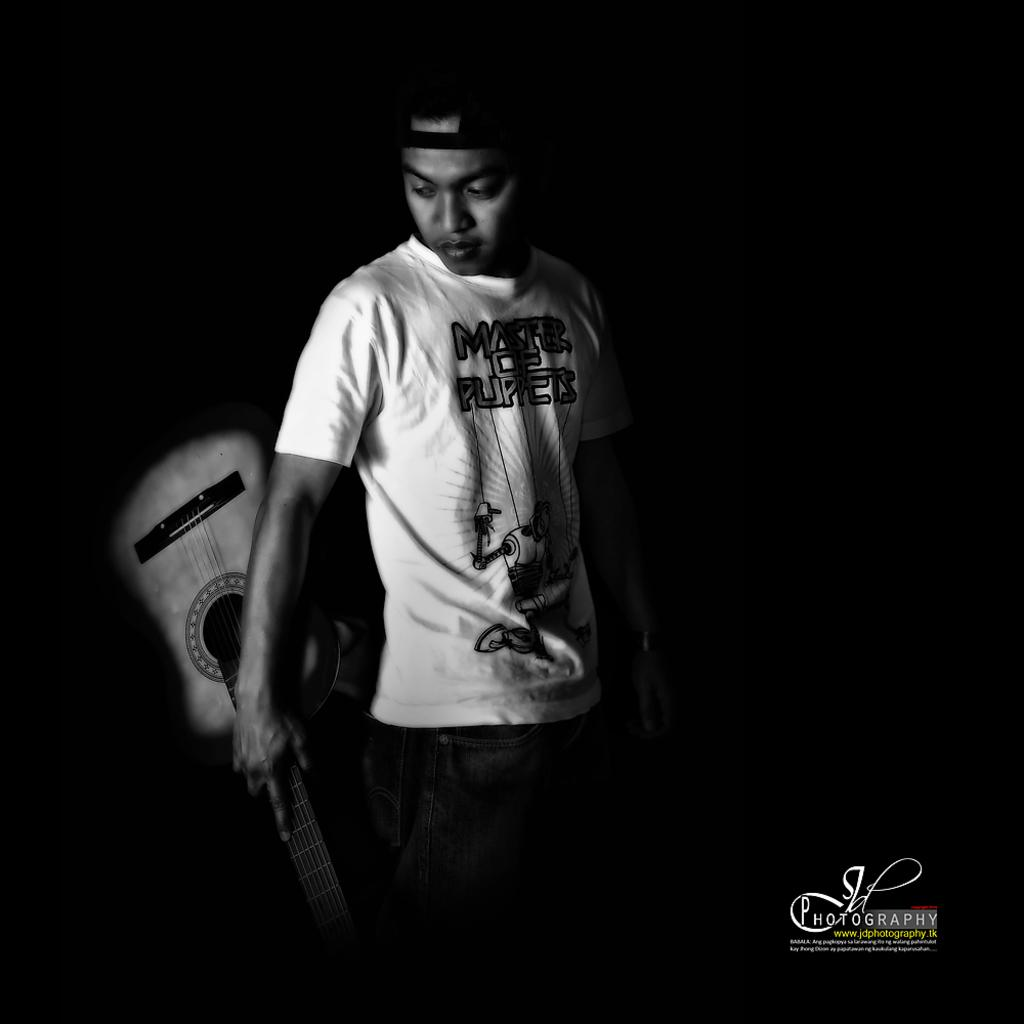Who is the main subject in the image? There is a boy in the image. What is the boy wearing on his head? The boy is wearing a cap. What is the boy holding in the image? The boy is holding a guitar. What can be observed about the background of the image? The background of the image is dark. How many pizzas are being served to the family in the image? There is no family or pizzas present in the image; it features a boy holding a guitar. 